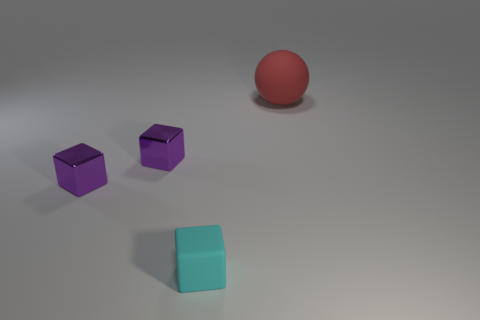Is there a purple object that has the same shape as the small cyan thing?
Your answer should be compact. Yes. What shape is the matte object in front of the object that is right of the tiny cyan object?
Your answer should be very brief. Cube. What number of cylinders are either big red things or metal things?
Your response must be concise. 0. There is a matte thing that is behind the small rubber block; is it the same shape as the matte object that is in front of the large rubber object?
Your response must be concise. No. How many other objects are there of the same color as the big ball?
Offer a very short reply. 0. What size is the rubber object to the right of the rubber object to the left of the matte thing behind the cyan block?
Offer a terse response. Large. Are there any tiny objects left of the red ball?
Your answer should be compact. Yes. Do the cyan block and the rubber thing that is on the right side of the tiny cyan matte cube have the same size?
Provide a short and direct response. No. How many other things are made of the same material as the cyan object?
Ensure brevity in your answer.  1. There is a object that is on the right side of the rubber block; is it the same size as the matte thing left of the red ball?
Offer a very short reply. No. 